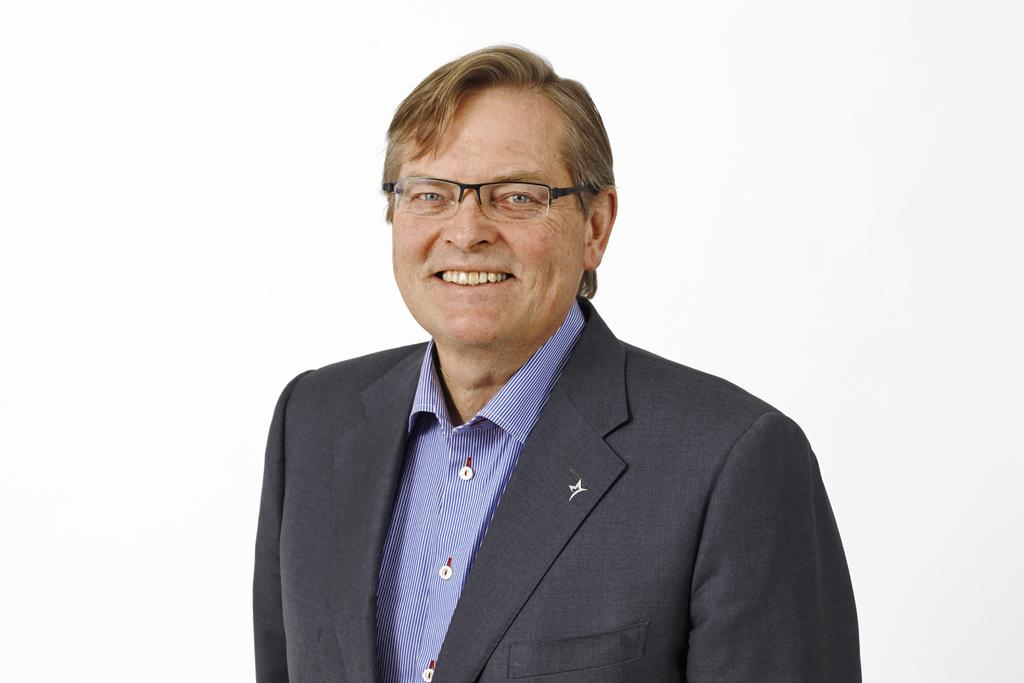What is the main subject of the image? There is a person in the image. What is the person's facial expression? The person is smiling. What color and pattern is the person's dress? The person is wearing a purple and black color dress. What color is the background of the image? The background of the image is white. What type of air can be seen in the image? There is no air visible in the image; it is a photograph of a person wearing a dress with a white background. What kind of experience does the person in the image have? The image does not provide any information about the person's experiences. 